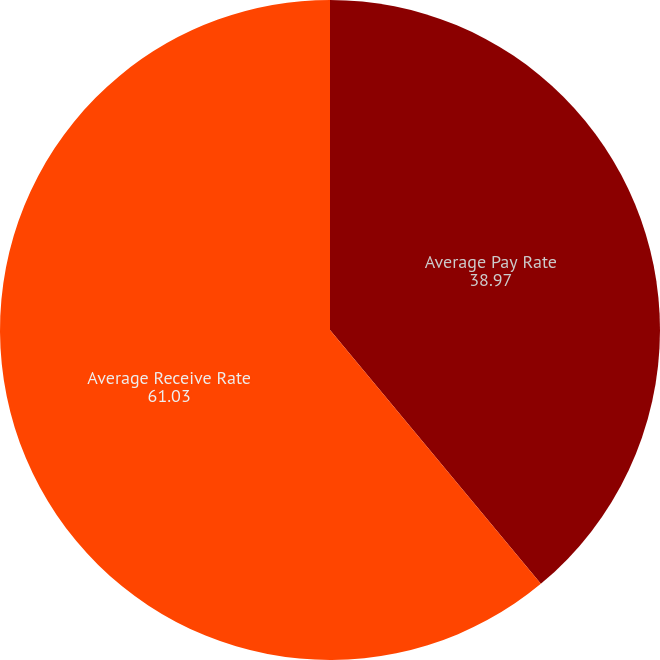<chart> <loc_0><loc_0><loc_500><loc_500><pie_chart><fcel>Average Pay Rate<fcel>Average Receive Rate<nl><fcel>38.97%<fcel>61.03%<nl></chart> 